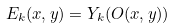<formula> <loc_0><loc_0><loc_500><loc_500>E _ { k } ( x , y ) = Y _ { k } ( O ( x , y ) )</formula> 